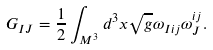<formula> <loc_0><loc_0><loc_500><loc_500>G _ { I J } = \frac { 1 } { 2 } \int _ { M ^ { 3 } } d ^ { 3 } x \sqrt { g } \omega _ { I i j } \omega _ { J } ^ { i j } .</formula> 